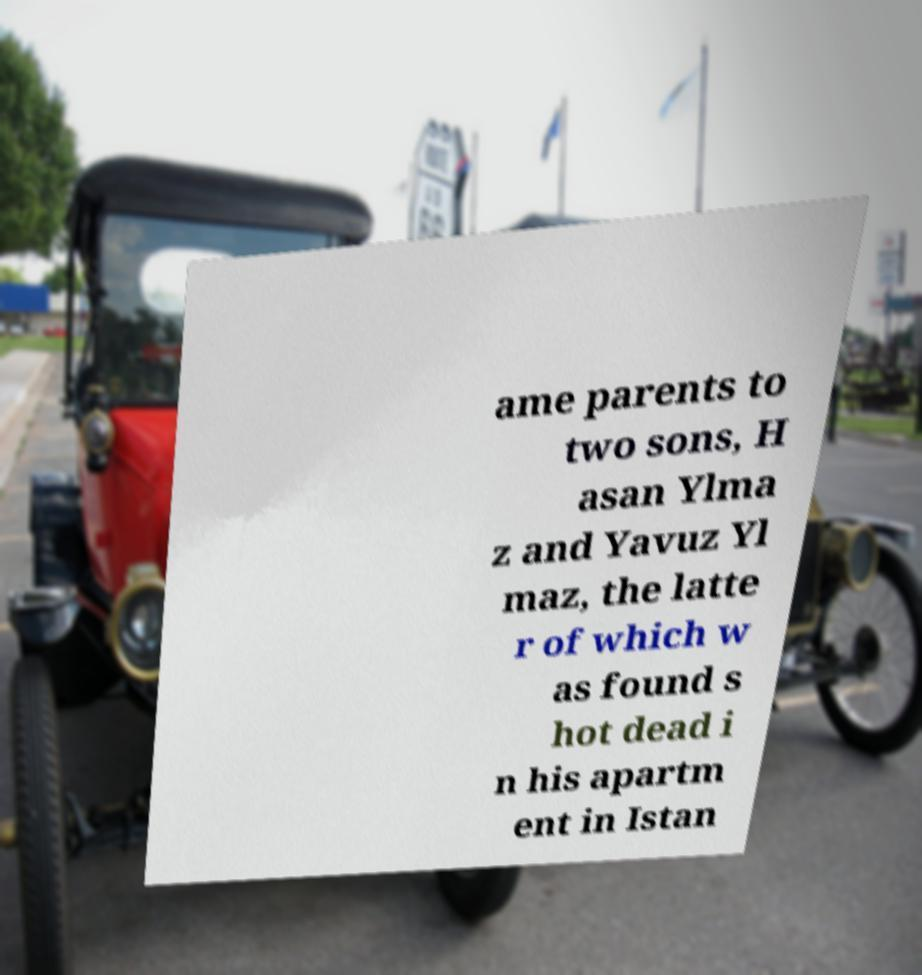Could you assist in decoding the text presented in this image and type it out clearly? ame parents to two sons, H asan Ylma z and Yavuz Yl maz, the latte r of which w as found s hot dead i n his apartm ent in Istan 